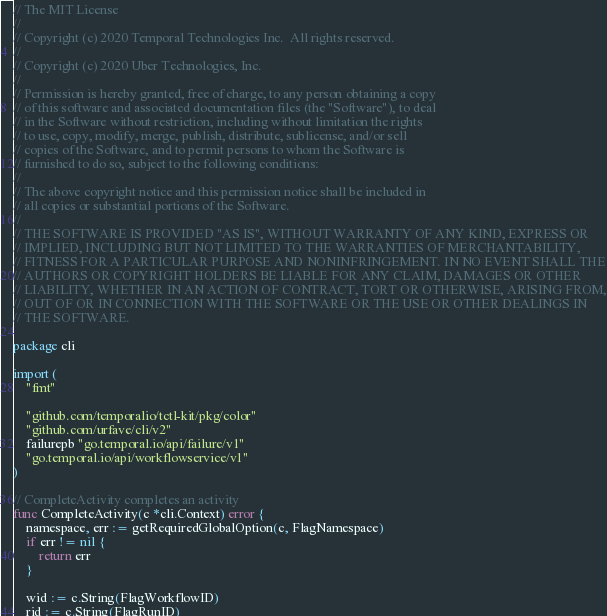Convert code to text. <code><loc_0><loc_0><loc_500><loc_500><_Go_>// The MIT License
//
// Copyright (c) 2020 Temporal Technologies Inc.  All rights reserved.
//
// Copyright (c) 2020 Uber Technologies, Inc.
//
// Permission is hereby granted, free of charge, to any person obtaining a copy
// of this software and associated documentation files (the "Software"), to deal
// in the Software without restriction, including without limitation the rights
// to use, copy, modify, merge, publish, distribute, sublicense, and/or sell
// copies of the Software, and to permit persons to whom the Software is
// furnished to do so, subject to the following conditions:
//
// The above copyright notice and this permission notice shall be included in
// all copies or substantial portions of the Software.
//
// THE SOFTWARE IS PROVIDED "AS IS", WITHOUT WARRANTY OF ANY KIND, EXPRESS OR
// IMPLIED, INCLUDING BUT NOT LIMITED TO THE WARRANTIES OF MERCHANTABILITY,
// FITNESS FOR A PARTICULAR PURPOSE AND NONINFRINGEMENT. IN NO EVENT SHALL THE
// AUTHORS OR COPYRIGHT HOLDERS BE LIABLE FOR ANY CLAIM, DAMAGES OR OTHER
// LIABILITY, WHETHER IN AN ACTION OF CONTRACT, TORT OR OTHERWISE, ARISING FROM,
// OUT OF OR IN CONNECTION WITH THE SOFTWARE OR THE USE OR OTHER DEALINGS IN
// THE SOFTWARE.

package cli

import (
	"fmt"

	"github.com/temporalio/tctl-kit/pkg/color"
	"github.com/urfave/cli/v2"
	failurepb "go.temporal.io/api/failure/v1"
	"go.temporal.io/api/workflowservice/v1"
)

// CompleteActivity completes an activity
func CompleteActivity(c *cli.Context) error {
	namespace, err := getRequiredGlobalOption(c, FlagNamespace)
	if err != nil {
		return err
	}

	wid := c.String(FlagWorkflowID)
	rid := c.String(FlagRunID)</code> 